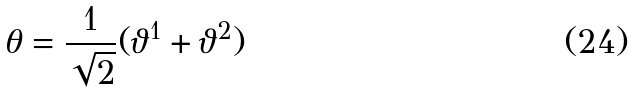Convert formula to latex. <formula><loc_0><loc_0><loc_500><loc_500>\theta = \frac { 1 } { \sqrt { 2 } } ( \vartheta ^ { 1 } + \vartheta ^ { 2 } )</formula> 